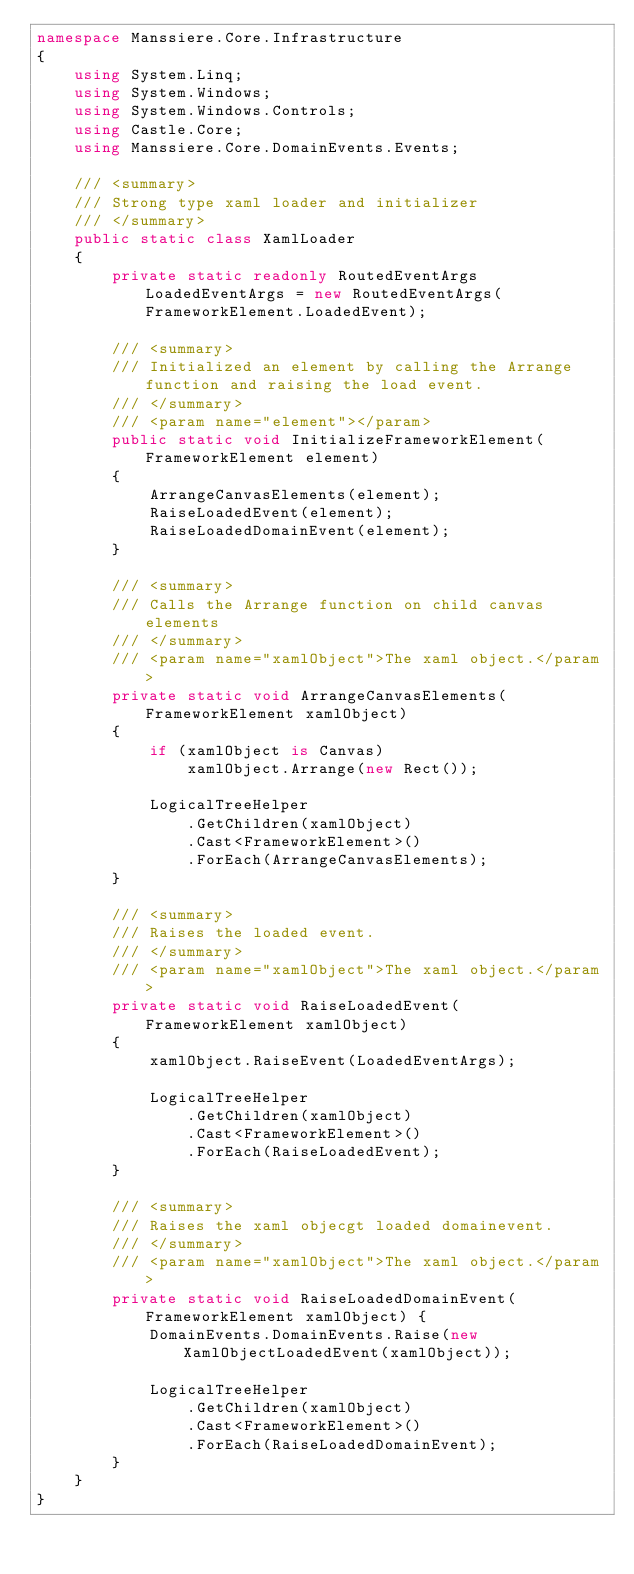Convert code to text. <code><loc_0><loc_0><loc_500><loc_500><_C#_>namespace Manssiere.Core.Infrastructure
{
    using System.Linq;
    using System.Windows;
    using System.Windows.Controls;
    using Castle.Core;
    using Manssiere.Core.DomainEvents.Events;

    /// <summary>
    /// Strong type xaml loader and initializer
    /// </summary>
    public static class XamlLoader
    {
        private static readonly RoutedEventArgs LoadedEventArgs = new RoutedEventArgs(FrameworkElement.LoadedEvent);

        /// <summary>
        /// Initialized an element by calling the Arrange function and raising the load event.
        /// </summary>
        /// <param name="element"></param>
        public static void InitializeFrameworkElement(FrameworkElement element)
        {
            ArrangeCanvasElements(element);
            RaiseLoadedEvent(element);
            RaiseLoadedDomainEvent(element);           
        }

        /// <summary>
        /// Calls the Arrange function on child canvas elements
        /// </summary>
        /// <param name="xamlObject">The xaml object.</param>
        private static void ArrangeCanvasElements(FrameworkElement xamlObject)
        {
            if (xamlObject is Canvas)
                xamlObject.Arrange(new Rect());

            LogicalTreeHelper
                .GetChildren(xamlObject)
                .Cast<FrameworkElement>()
                .ForEach(ArrangeCanvasElements);
        }

        /// <summary>
        /// Raises the loaded event.
        /// </summary>
        /// <param name="xamlObject">The xaml object.</param>
        private static void RaiseLoadedEvent(FrameworkElement xamlObject)
        {
            xamlObject.RaiseEvent(LoadedEventArgs);

            LogicalTreeHelper
                .GetChildren(xamlObject)
                .Cast<FrameworkElement>()
                .ForEach(RaiseLoadedEvent);
        }        

        /// <summary>
        /// Raises the xaml objecgt loaded domainevent.
        /// </summary>
        /// <param name="xamlObject">The xaml object.</param>
        private static void RaiseLoadedDomainEvent(FrameworkElement xamlObject) {
            DomainEvents.DomainEvents.Raise(new XamlObjectLoadedEvent(xamlObject));

            LogicalTreeHelper
                .GetChildren(xamlObject)
                .Cast<FrameworkElement>()
                .ForEach(RaiseLoadedDomainEvent);
        }
    }
}</code> 